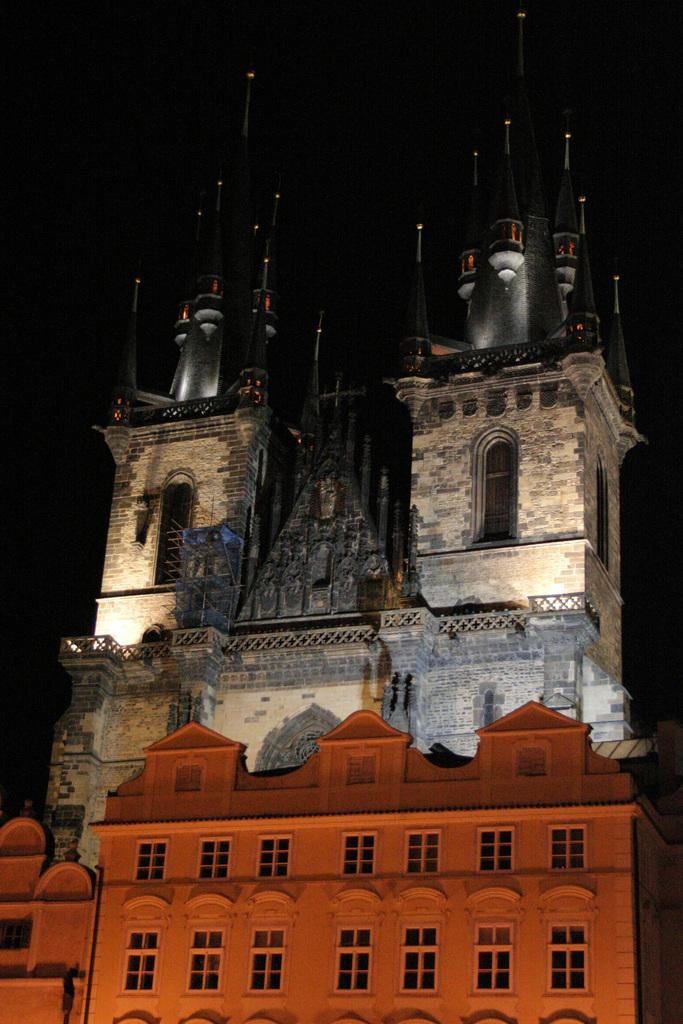What is the main subject of the image? The main subject of the image is the buildings in the center. What specific features can be observed on the buildings? The buildings have windows and railings. What is the color or lighting condition of the background in the image? The background of the image is dark. What type of cushion can be seen on the minister's chair in the image? There is no minister or chair present in the image, so there is no cushion to be seen. 